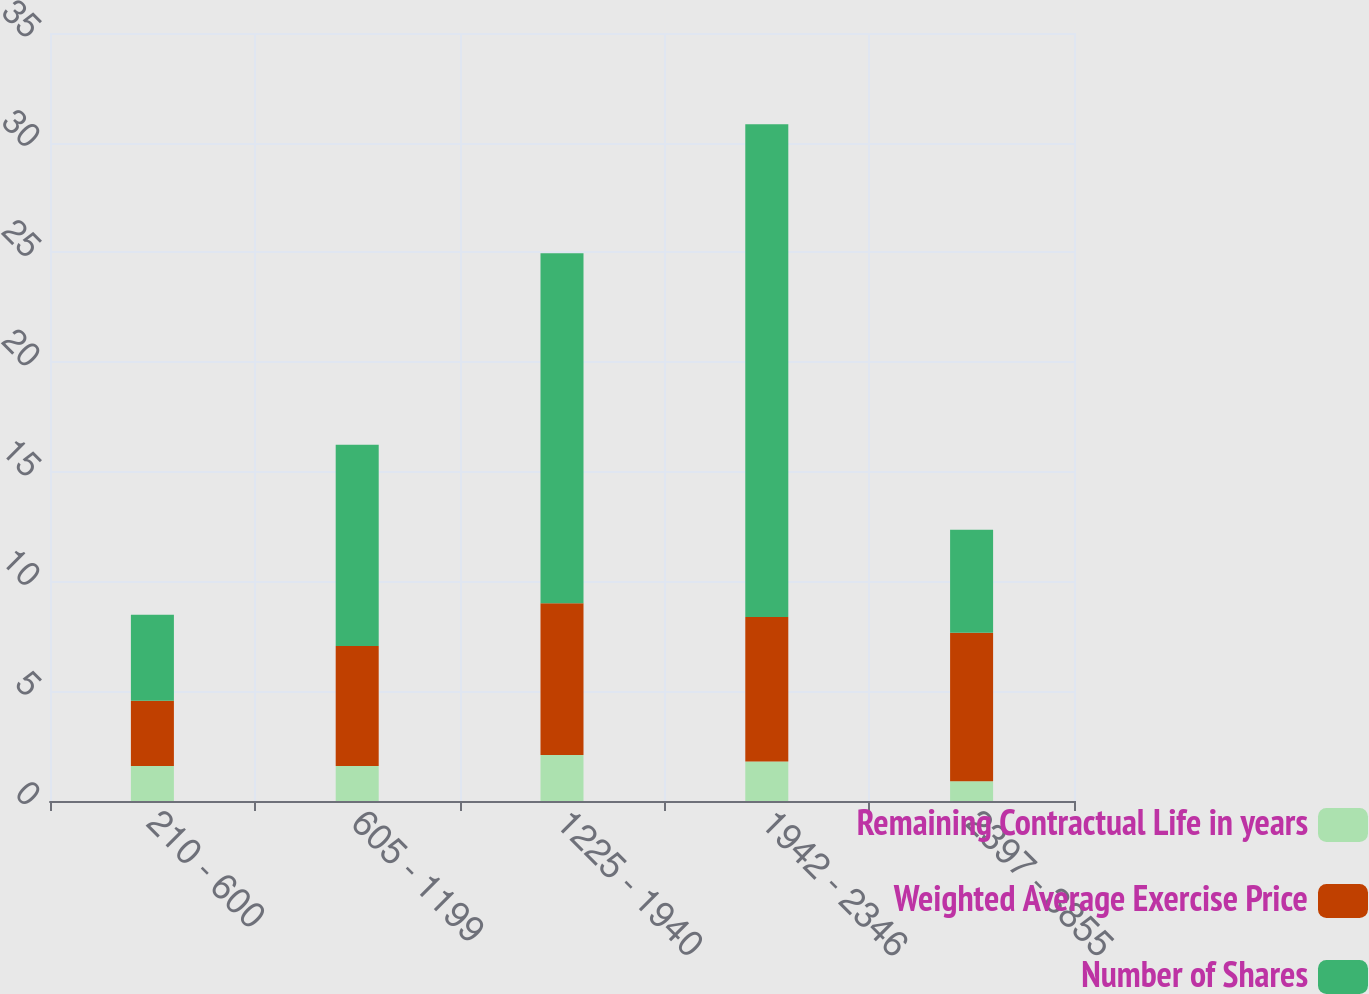Convert chart to OTSL. <chart><loc_0><loc_0><loc_500><loc_500><stacked_bar_chart><ecel><fcel>210 - 600<fcel>605 - 1199<fcel>1225 - 1940<fcel>1942 - 2346<fcel>2397 - 3855<nl><fcel>Remaining Contractual Life in years<fcel>1.6<fcel>1.6<fcel>2.1<fcel>1.8<fcel>0.9<nl><fcel>Weighted Average Exercise Price<fcel>2.97<fcel>5.46<fcel>6.91<fcel>6.59<fcel>6.77<nl><fcel>Number of Shares<fcel>3.92<fcel>9.18<fcel>15.95<fcel>22.45<fcel>4.69<nl></chart> 